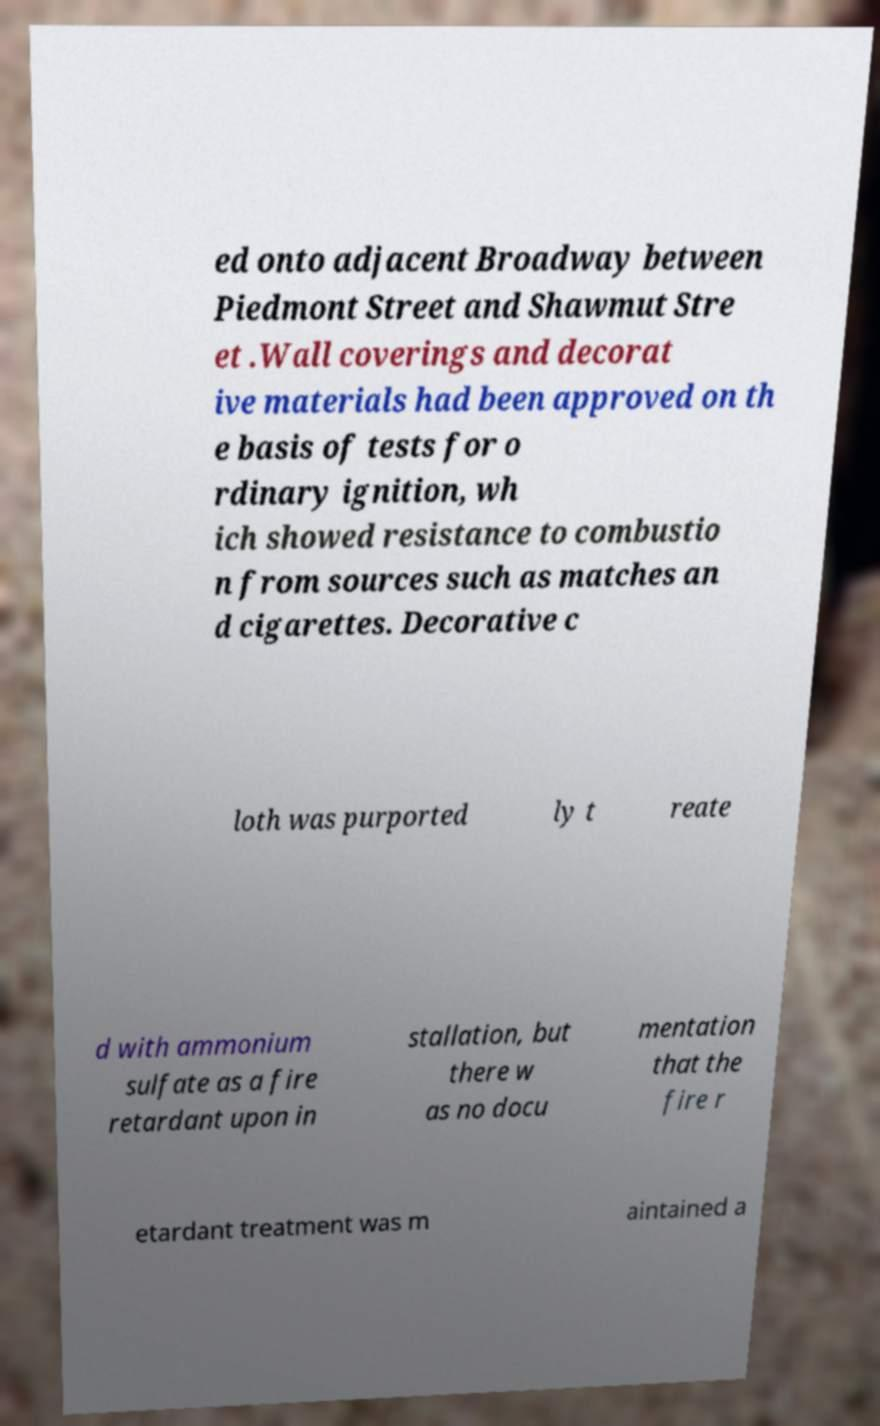Please identify and transcribe the text found in this image. ed onto adjacent Broadway between Piedmont Street and Shawmut Stre et .Wall coverings and decorat ive materials had been approved on th e basis of tests for o rdinary ignition, wh ich showed resistance to combustio n from sources such as matches an d cigarettes. Decorative c loth was purported ly t reate d with ammonium sulfate as a fire retardant upon in stallation, but there w as no docu mentation that the fire r etardant treatment was m aintained a 